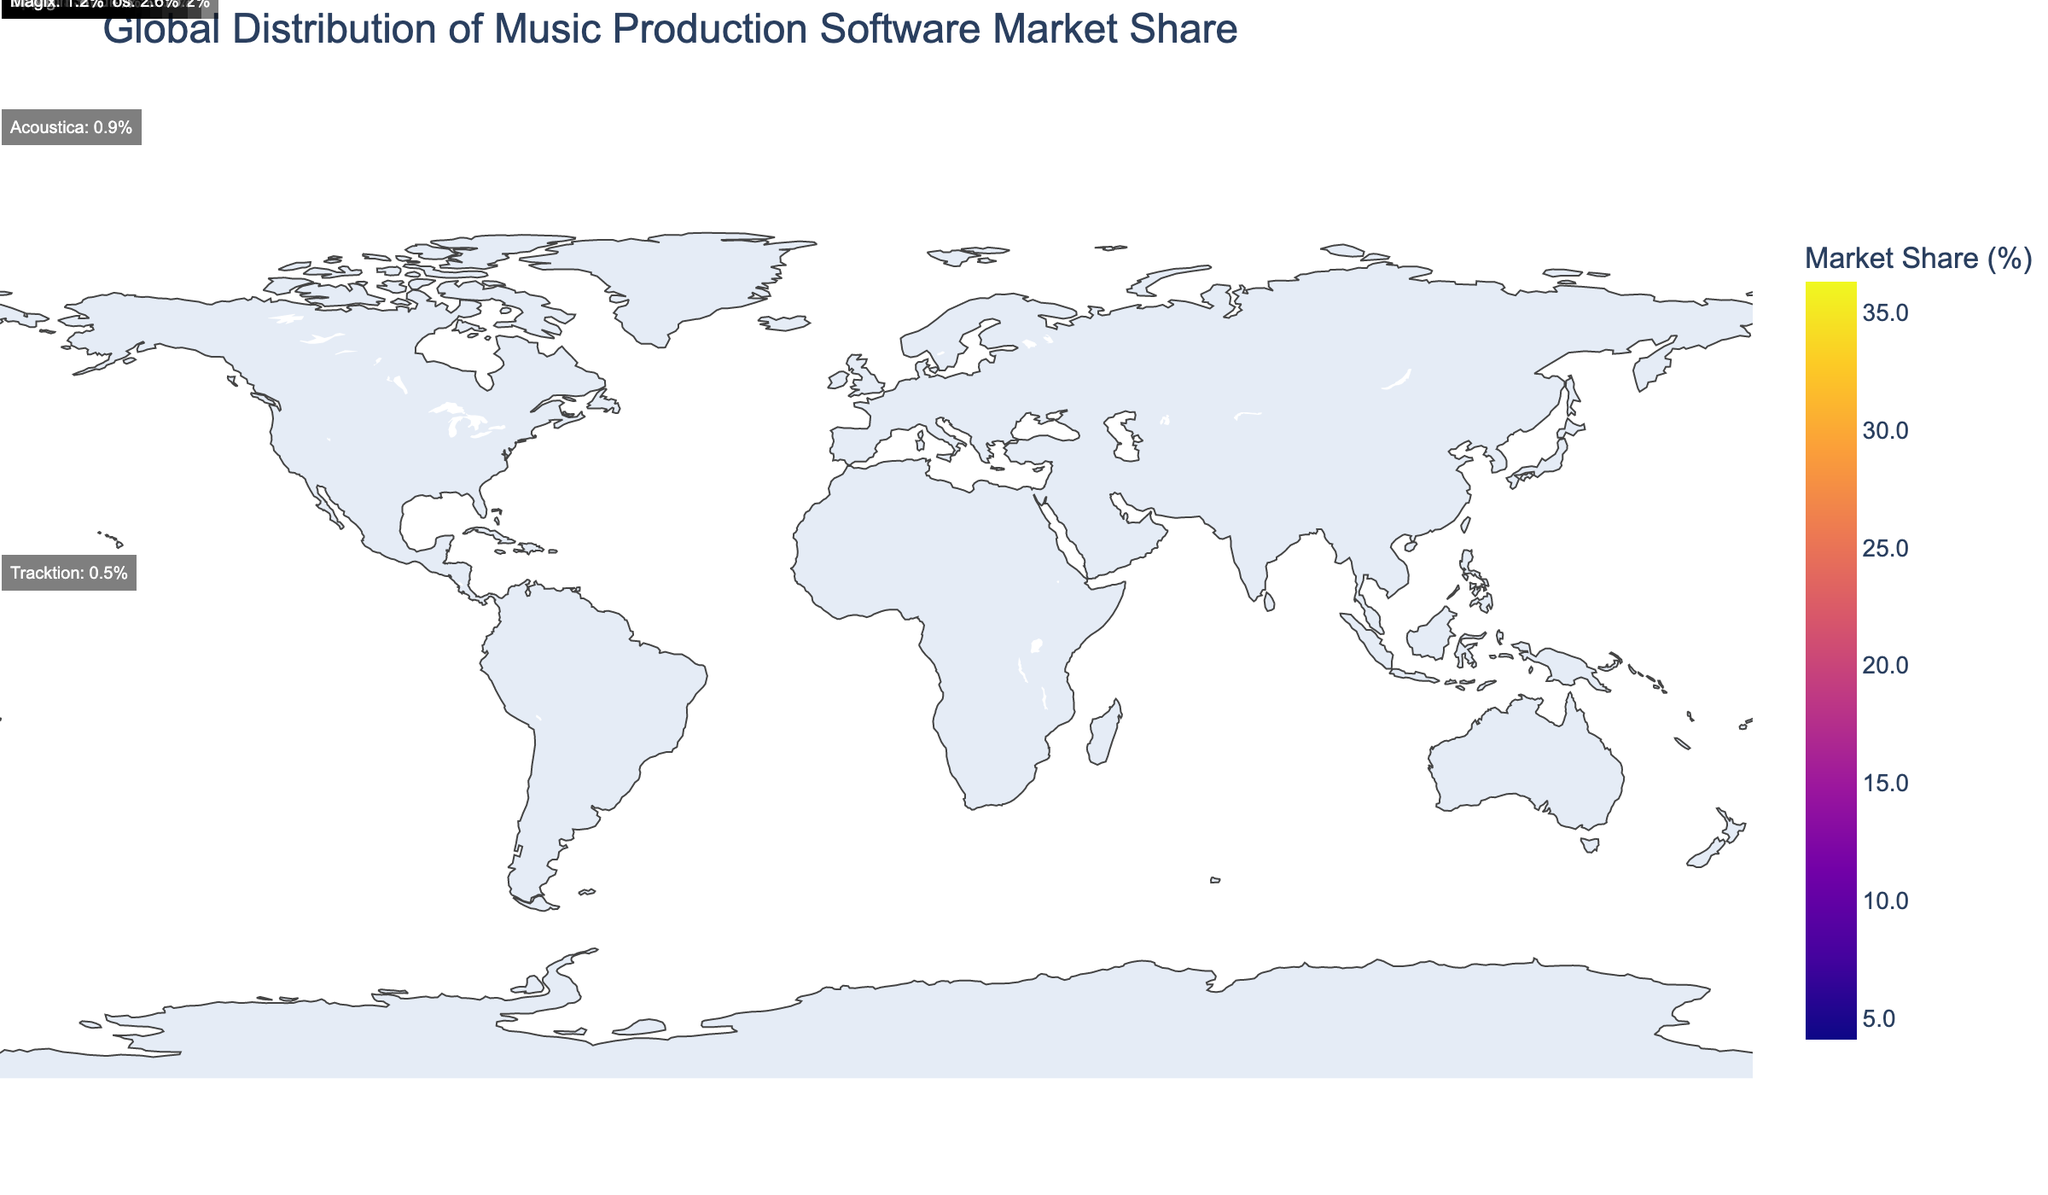What is the title of the plot? The title is prominently displayed at the top of the plot. It reads "Global Distribution of Music Production Software Market Share."
Answer: Global Distribution of Music Production Software Market Share Which region has the highest market share according to the plot? The color intensity in the plot indicates market share, with darker shades representing higher values. According to the plot, Europe has the highest market share.
Answer: Europe What is the market share percentage for Ableton in Europe? The annotations on the plot show that Ableton has a market share of 22.3% in Europe.
Answer: 22.3% How does the market share of Native Instruments in North America compare to Avid Technology? Native Instruments has a lower market share compared to Avid Technology in North America. The plot annotations show Native Instruments with 15.2% and Avid Technology with 18.5%.
Answer: Avid Technology > Native Instruments Which company has the lowest market share and in which region? According to the annotations, Tracktion has the lowest market share of 0.5% in the Middle East & Africa.
Answer: Tracktion, Middle East & Africa What is the total market share of the software companies in the Asia-Pacific region? The plot provides individual market shares for Steinberg (12.7%), Cockos (7.9%), and Magix (1.2%) in the Asia-Pacific region. Adding these values gives a total of 12.7 + 7.9 + 1.2 = 21.8%.
Answer: 21.8% Compare the total market share of companies in Latin America and the Middle East & Africa. In Latin America, PreSonus and Acoustica have market shares of 6.4% and 0.9% respectively. Their total is 6.4 + 0.9 = 7.3%. In the Middle East & Africa, Apple and Tracktion have market shares of 3.6% and 0.5%. Their total is 3.6 + 0.5 = 4.1%. Therefore, Latin America has a higher total market share than the Middle East & Africa.
Answer: Latin America > Middle East & Africa Which regions are colored with the least intense shades indicating lower market share, and what could be inferred about their market presence? The regions with the least intense shades are the Middle East & Africa and Latin America. This indicates that these regions have a relatively low market share compared to others, suggesting a smaller market presence in these areas.
Answer: Middle East & Africa, Latin America What is the combined market share of all companies listed in the North American region? The plot annotations reveal the market shares for Avid Technology (18.5%), Native Instruments (15.2%), and Reason Studios (2.6%). Adding these values gives 18.5 + 15.2 + 2.6 = 36.3%.
Answer: 36.3% 